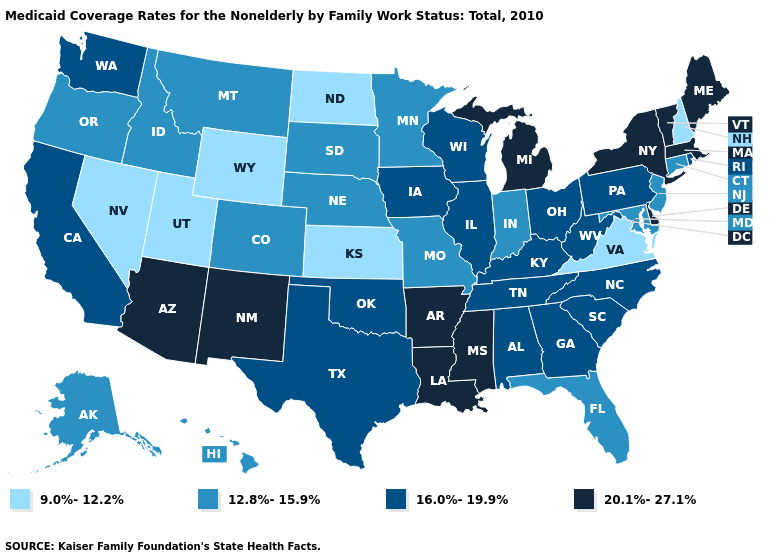Name the states that have a value in the range 20.1%-27.1%?
Give a very brief answer. Arizona, Arkansas, Delaware, Louisiana, Maine, Massachusetts, Michigan, Mississippi, New Mexico, New York, Vermont. What is the value of Kentucky?
Give a very brief answer. 16.0%-19.9%. Does New York have the highest value in the Northeast?
Answer briefly. Yes. Does Vermont have the lowest value in the USA?
Give a very brief answer. No. What is the value of Tennessee?
Quick response, please. 16.0%-19.9%. Does the first symbol in the legend represent the smallest category?
Be succinct. Yes. Which states have the lowest value in the MidWest?
Be succinct. Kansas, North Dakota. What is the value of Missouri?
Give a very brief answer. 12.8%-15.9%. Which states have the lowest value in the USA?
Write a very short answer. Kansas, Nevada, New Hampshire, North Dakota, Utah, Virginia, Wyoming. Name the states that have a value in the range 9.0%-12.2%?
Quick response, please. Kansas, Nevada, New Hampshire, North Dakota, Utah, Virginia, Wyoming. Name the states that have a value in the range 16.0%-19.9%?
Keep it brief. Alabama, California, Georgia, Illinois, Iowa, Kentucky, North Carolina, Ohio, Oklahoma, Pennsylvania, Rhode Island, South Carolina, Tennessee, Texas, Washington, West Virginia, Wisconsin. What is the value of Oklahoma?
Be succinct. 16.0%-19.9%. What is the highest value in states that border Nebraska?
Short answer required. 16.0%-19.9%. What is the lowest value in the South?
Keep it brief. 9.0%-12.2%. Among the states that border New Hampshire , which have the highest value?
Short answer required. Maine, Massachusetts, Vermont. 